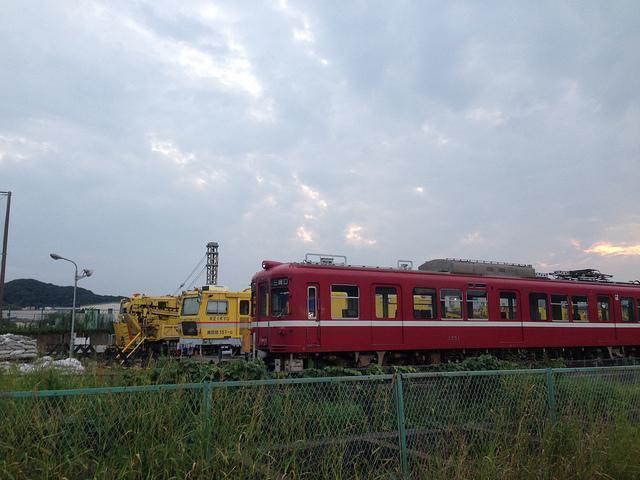How many different color style are on each of thes buses?
Give a very brief answer. 2. How many trains are there?
Give a very brief answer. 2. How many colors are on the train?
Give a very brief answer. 2. How many train cars are in the picture?
Give a very brief answer. 1. How many trains are in the picture?
Give a very brief answer. 1. How many trains are on the track?
Give a very brief answer. 1. How many people are in this picture?
Give a very brief answer. 0. 